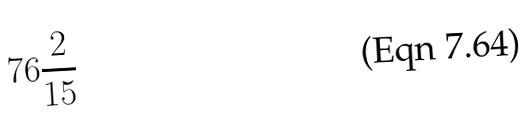<formula> <loc_0><loc_0><loc_500><loc_500>7 6 \frac { 2 } { 1 5 }</formula> 